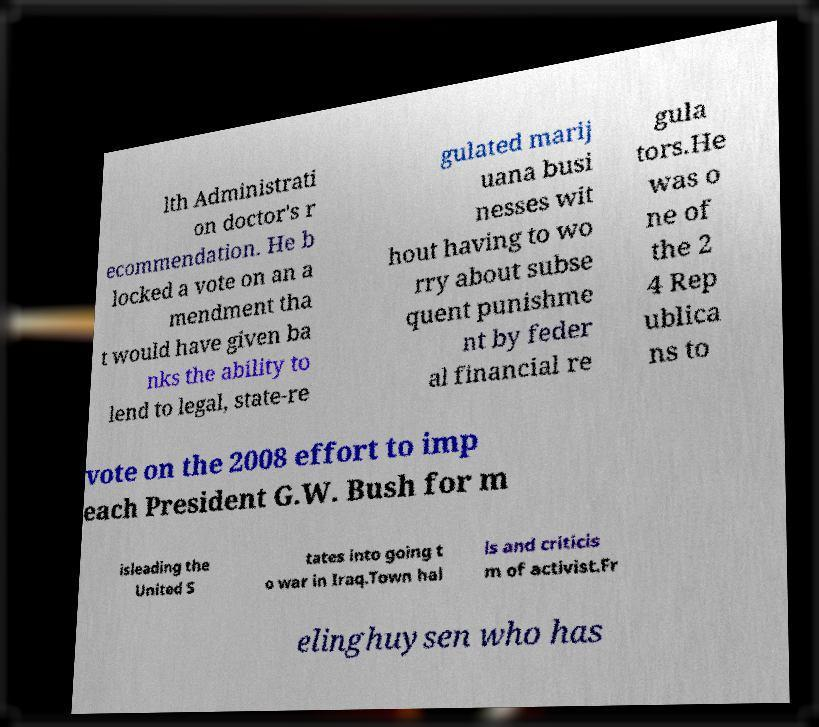What messages or text are displayed in this image? I need them in a readable, typed format. lth Administrati on doctor's r ecommendation. He b locked a vote on an a mendment tha t would have given ba nks the ability to lend to legal, state-re gulated marij uana busi nesses wit hout having to wo rry about subse quent punishme nt by feder al financial re gula tors.He was o ne of the 2 4 Rep ublica ns to vote on the 2008 effort to imp each President G.W. Bush for m isleading the United S tates into going t o war in Iraq.Town hal ls and criticis m of activist.Fr elinghuysen who has 